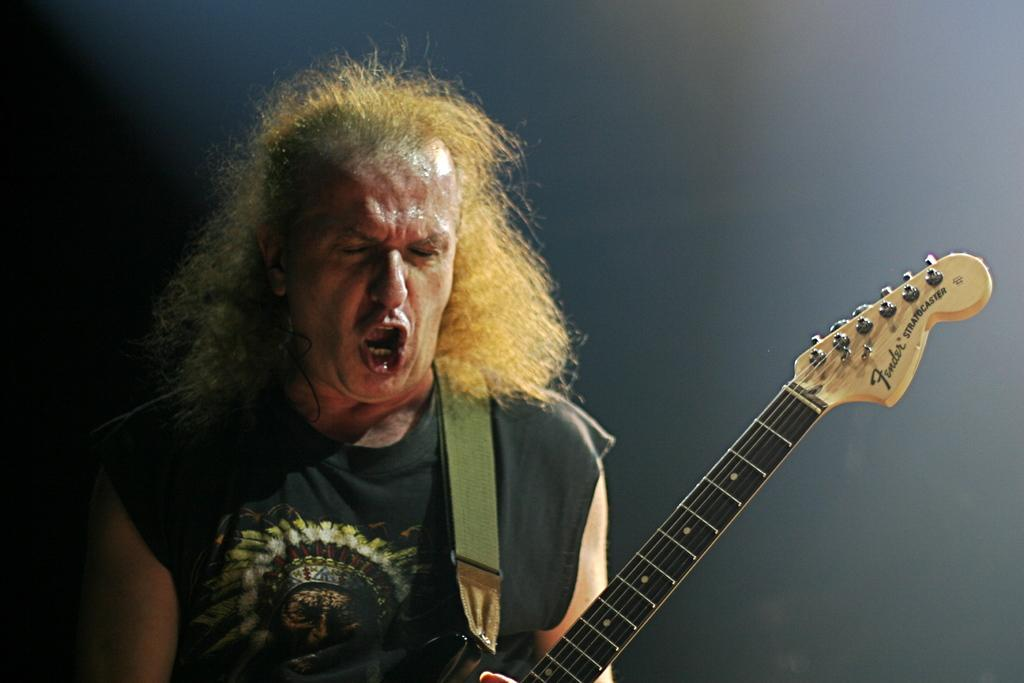What is the main subject of the image? The main subject of the image is a man. What is the man holding in the image? The man is holding a guitar in the image. What is the man doing with the guitar? The man is singing while holding the guitar. What type of furniture is the man sitting on in the image? There is no furniture present in the image; the man is standing while holding the guitar. What drug is the man using in the image? There is no drug use depicted in the image; the man is simply singing while holding a guitar. 